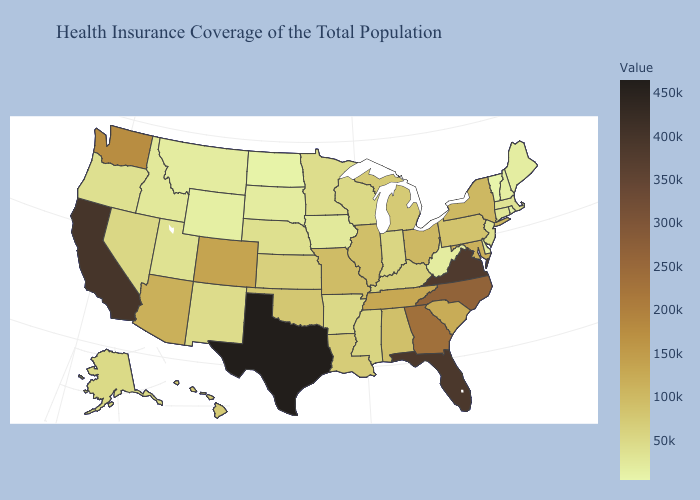Among the states that border New York , does New Jersey have the lowest value?
Answer briefly. No. Which states hav the highest value in the MidWest?
Short answer required. Ohio. Does New Hampshire have the lowest value in the Northeast?
Write a very short answer. No. 